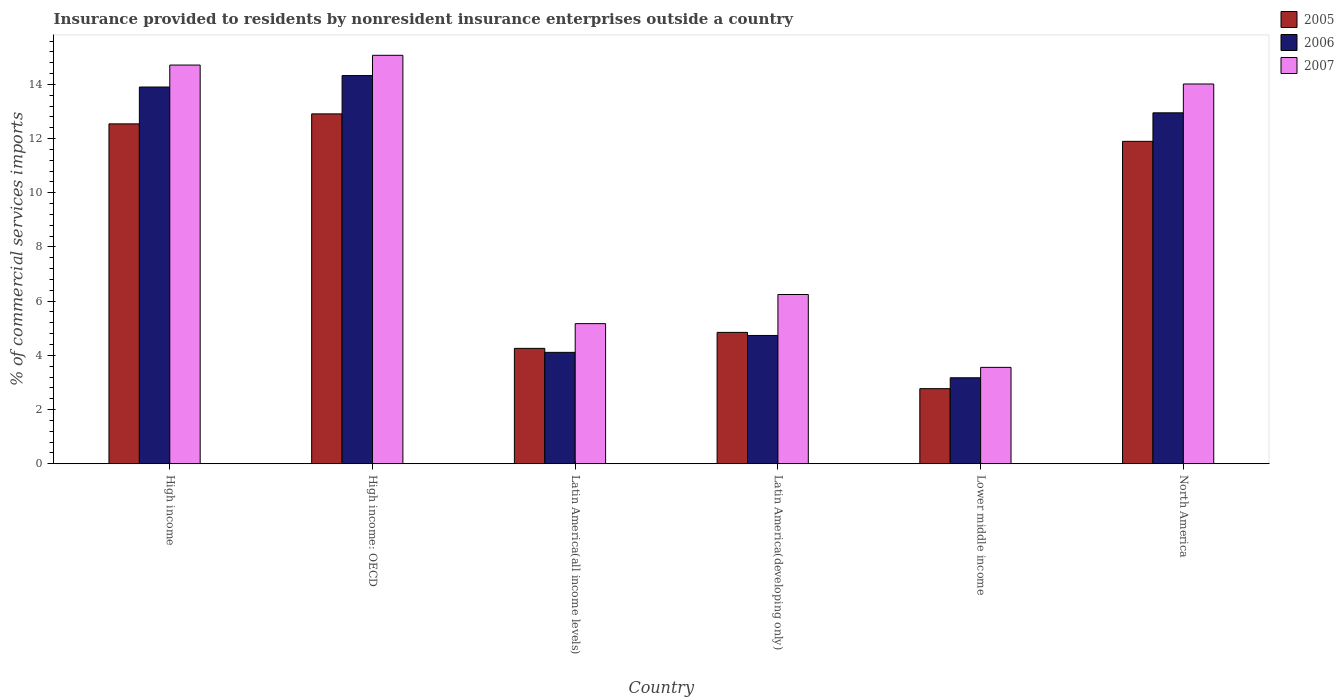Are the number of bars per tick equal to the number of legend labels?
Keep it short and to the point. Yes. How many bars are there on the 1st tick from the right?
Ensure brevity in your answer.  3. What is the label of the 5th group of bars from the left?
Provide a short and direct response. Lower middle income. In how many cases, is the number of bars for a given country not equal to the number of legend labels?
Keep it short and to the point. 0. What is the Insurance provided to residents in 2006 in Lower middle income?
Offer a very short reply. 3.17. Across all countries, what is the maximum Insurance provided to residents in 2006?
Provide a short and direct response. 14.33. Across all countries, what is the minimum Insurance provided to residents in 2007?
Make the answer very short. 3.56. In which country was the Insurance provided to residents in 2005 maximum?
Give a very brief answer. High income: OECD. In which country was the Insurance provided to residents in 2005 minimum?
Offer a very short reply. Lower middle income. What is the total Insurance provided to residents in 2006 in the graph?
Make the answer very short. 53.19. What is the difference between the Insurance provided to residents in 2007 in High income and that in Lower middle income?
Ensure brevity in your answer.  11.16. What is the difference between the Insurance provided to residents in 2007 in High income and the Insurance provided to residents in 2006 in North America?
Provide a succinct answer. 1.76. What is the average Insurance provided to residents in 2005 per country?
Ensure brevity in your answer.  8.2. What is the difference between the Insurance provided to residents of/in 2006 and Insurance provided to residents of/in 2007 in Lower middle income?
Provide a short and direct response. -0.38. In how many countries, is the Insurance provided to residents in 2006 greater than 1.6 %?
Ensure brevity in your answer.  6. What is the ratio of the Insurance provided to residents in 2005 in High income to that in Latin America(all income levels)?
Offer a very short reply. 2.95. What is the difference between the highest and the second highest Insurance provided to residents in 2005?
Give a very brief answer. -1.01. What is the difference between the highest and the lowest Insurance provided to residents in 2007?
Keep it short and to the point. 11.52. What is the difference between two consecutive major ticks on the Y-axis?
Provide a short and direct response. 2. Are the values on the major ticks of Y-axis written in scientific E-notation?
Keep it short and to the point. No. How are the legend labels stacked?
Your answer should be very brief. Vertical. What is the title of the graph?
Offer a terse response. Insurance provided to residents by nonresident insurance enterprises outside a country. Does "1972" appear as one of the legend labels in the graph?
Keep it short and to the point. No. What is the label or title of the X-axis?
Give a very brief answer. Country. What is the label or title of the Y-axis?
Give a very brief answer. % of commercial services imports. What is the % of commercial services imports in 2005 in High income?
Provide a succinct answer. 12.54. What is the % of commercial services imports of 2006 in High income?
Provide a succinct answer. 13.9. What is the % of commercial services imports of 2007 in High income?
Offer a very short reply. 14.71. What is the % of commercial services imports in 2005 in High income: OECD?
Your answer should be compact. 12.91. What is the % of commercial services imports in 2006 in High income: OECD?
Provide a succinct answer. 14.33. What is the % of commercial services imports of 2007 in High income: OECD?
Give a very brief answer. 15.07. What is the % of commercial services imports of 2005 in Latin America(all income levels)?
Offer a terse response. 4.26. What is the % of commercial services imports of 2006 in Latin America(all income levels)?
Offer a terse response. 4.11. What is the % of commercial services imports in 2007 in Latin America(all income levels)?
Provide a succinct answer. 5.17. What is the % of commercial services imports of 2005 in Latin America(developing only)?
Your answer should be compact. 4.85. What is the % of commercial services imports in 2006 in Latin America(developing only)?
Ensure brevity in your answer.  4.73. What is the % of commercial services imports of 2007 in Latin America(developing only)?
Make the answer very short. 6.25. What is the % of commercial services imports of 2005 in Lower middle income?
Provide a short and direct response. 2.77. What is the % of commercial services imports in 2006 in Lower middle income?
Offer a very short reply. 3.17. What is the % of commercial services imports of 2007 in Lower middle income?
Your answer should be compact. 3.56. What is the % of commercial services imports in 2005 in North America?
Offer a very short reply. 11.9. What is the % of commercial services imports of 2006 in North America?
Offer a terse response. 12.95. What is the % of commercial services imports in 2007 in North America?
Make the answer very short. 14.01. Across all countries, what is the maximum % of commercial services imports in 2005?
Provide a succinct answer. 12.91. Across all countries, what is the maximum % of commercial services imports in 2006?
Offer a very short reply. 14.33. Across all countries, what is the maximum % of commercial services imports in 2007?
Offer a very short reply. 15.07. Across all countries, what is the minimum % of commercial services imports of 2005?
Provide a succinct answer. 2.77. Across all countries, what is the minimum % of commercial services imports in 2006?
Your answer should be compact. 3.17. Across all countries, what is the minimum % of commercial services imports of 2007?
Provide a short and direct response. 3.56. What is the total % of commercial services imports in 2005 in the graph?
Your answer should be very brief. 49.23. What is the total % of commercial services imports of 2006 in the graph?
Provide a succinct answer. 53.19. What is the total % of commercial services imports of 2007 in the graph?
Offer a terse response. 58.77. What is the difference between the % of commercial services imports of 2005 in High income and that in High income: OECD?
Your answer should be very brief. -0.37. What is the difference between the % of commercial services imports in 2006 in High income and that in High income: OECD?
Ensure brevity in your answer.  -0.42. What is the difference between the % of commercial services imports of 2007 in High income and that in High income: OECD?
Provide a succinct answer. -0.36. What is the difference between the % of commercial services imports of 2005 in High income and that in Latin America(all income levels)?
Keep it short and to the point. 8.28. What is the difference between the % of commercial services imports in 2006 in High income and that in Latin America(all income levels)?
Your answer should be very brief. 9.79. What is the difference between the % of commercial services imports of 2007 in High income and that in Latin America(all income levels)?
Keep it short and to the point. 9.54. What is the difference between the % of commercial services imports in 2005 in High income and that in Latin America(developing only)?
Give a very brief answer. 7.69. What is the difference between the % of commercial services imports of 2006 in High income and that in Latin America(developing only)?
Keep it short and to the point. 9.17. What is the difference between the % of commercial services imports in 2007 in High income and that in Latin America(developing only)?
Your answer should be compact. 8.47. What is the difference between the % of commercial services imports in 2005 in High income and that in Lower middle income?
Keep it short and to the point. 9.77. What is the difference between the % of commercial services imports of 2006 in High income and that in Lower middle income?
Make the answer very short. 10.73. What is the difference between the % of commercial services imports of 2007 in High income and that in Lower middle income?
Your answer should be compact. 11.16. What is the difference between the % of commercial services imports in 2005 in High income and that in North America?
Your response must be concise. 0.64. What is the difference between the % of commercial services imports of 2006 in High income and that in North America?
Make the answer very short. 0.95. What is the difference between the % of commercial services imports in 2007 in High income and that in North America?
Offer a terse response. 0.7. What is the difference between the % of commercial services imports in 2005 in High income: OECD and that in Latin America(all income levels)?
Keep it short and to the point. 8.65. What is the difference between the % of commercial services imports in 2006 in High income: OECD and that in Latin America(all income levels)?
Provide a short and direct response. 10.21. What is the difference between the % of commercial services imports of 2007 in High income: OECD and that in Latin America(all income levels)?
Your answer should be compact. 9.9. What is the difference between the % of commercial services imports in 2005 in High income: OECD and that in Latin America(developing only)?
Provide a succinct answer. 8.06. What is the difference between the % of commercial services imports in 2006 in High income: OECD and that in Latin America(developing only)?
Offer a very short reply. 9.59. What is the difference between the % of commercial services imports of 2007 in High income: OECD and that in Latin America(developing only)?
Make the answer very short. 8.83. What is the difference between the % of commercial services imports of 2005 in High income: OECD and that in Lower middle income?
Provide a short and direct response. 10.14. What is the difference between the % of commercial services imports in 2006 in High income: OECD and that in Lower middle income?
Keep it short and to the point. 11.15. What is the difference between the % of commercial services imports in 2007 in High income: OECD and that in Lower middle income?
Make the answer very short. 11.52. What is the difference between the % of commercial services imports of 2005 in High income: OECD and that in North America?
Keep it short and to the point. 1.01. What is the difference between the % of commercial services imports in 2006 in High income: OECD and that in North America?
Keep it short and to the point. 1.38. What is the difference between the % of commercial services imports in 2007 in High income: OECD and that in North America?
Your answer should be compact. 1.06. What is the difference between the % of commercial services imports in 2005 in Latin America(all income levels) and that in Latin America(developing only)?
Keep it short and to the point. -0.59. What is the difference between the % of commercial services imports in 2006 in Latin America(all income levels) and that in Latin America(developing only)?
Ensure brevity in your answer.  -0.62. What is the difference between the % of commercial services imports of 2007 in Latin America(all income levels) and that in Latin America(developing only)?
Give a very brief answer. -1.07. What is the difference between the % of commercial services imports of 2005 in Latin America(all income levels) and that in Lower middle income?
Your answer should be compact. 1.49. What is the difference between the % of commercial services imports in 2006 in Latin America(all income levels) and that in Lower middle income?
Give a very brief answer. 0.94. What is the difference between the % of commercial services imports of 2007 in Latin America(all income levels) and that in Lower middle income?
Offer a very short reply. 1.61. What is the difference between the % of commercial services imports in 2005 in Latin America(all income levels) and that in North America?
Keep it short and to the point. -7.64. What is the difference between the % of commercial services imports of 2006 in Latin America(all income levels) and that in North America?
Ensure brevity in your answer.  -8.84. What is the difference between the % of commercial services imports in 2007 in Latin America(all income levels) and that in North America?
Your answer should be very brief. -8.84. What is the difference between the % of commercial services imports in 2005 in Latin America(developing only) and that in Lower middle income?
Ensure brevity in your answer.  2.08. What is the difference between the % of commercial services imports of 2006 in Latin America(developing only) and that in Lower middle income?
Give a very brief answer. 1.56. What is the difference between the % of commercial services imports in 2007 in Latin America(developing only) and that in Lower middle income?
Provide a succinct answer. 2.69. What is the difference between the % of commercial services imports of 2005 in Latin America(developing only) and that in North America?
Make the answer very short. -7.05. What is the difference between the % of commercial services imports of 2006 in Latin America(developing only) and that in North America?
Offer a very short reply. -8.22. What is the difference between the % of commercial services imports in 2007 in Latin America(developing only) and that in North America?
Make the answer very short. -7.77. What is the difference between the % of commercial services imports of 2005 in Lower middle income and that in North America?
Keep it short and to the point. -9.13. What is the difference between the % of commercial services imports of 2006 in Lower middle income and that in North America?
Offer a very short reply. -9.78. What is the difference between the % of commercial services imports of 2007 in Lower middle income and that in North America?
Your answer should be compact. -10.46. What is the difference between the % of commercial services imports of 2005 in High income and the % of commercial services imports of 2006 in High income: OECD?
Offer a terse response. -1.78. What is the difference between the % of commercial services imports in 2005 in High income and the % of commercial services imports in 2007 in High income: OECD?
Your answer should be compact. -2.53. What is the difference between the % of commercial services imports in 2006 in High income and the % of commercial services imports in 2007 in High income: OECD?
Provide a short and direct response. -1.17. What is the difference between the % of commercial services imports of 2005 in High income and the % of commercial services imports of 2006 in Latin America(all income levels)?
Offer a very short reply. 8.43. What is the difference between the % of commercial services imports in 2005 in High income and the % of commercial services imports in 2007 in Latin America(all income levels)?
Ensure brevity in your answer.  7.37. What is the difference between the % of commercial services imports of 2006 in High income and the % of commercial services imports of 2007 in Latin America(all income levels)?
Offer a terse response. 8.73. What is the difference between the % of commercial services imports in 2005 in High income and the % of commercial services imports in 2006 in Latin America(developing only)?
Keep it short and to the point. 7.81. What is the difference between the % of commercial services imports of 2005 in High income and the % of commercial services imports of 2007 in Latin America(developing only)?
Your answer should be very brief. 6.3. What is the difference between the % of commercial services imports in 2006 in High income and the % of commercial services imports in 2007 in Latin America(developing only)?
Your answer should be very brief. 7.66. What is the difference between the % of commercial services imports of 2005 in High income and the % of commercial services imports of 2006 in Lower middle income?
Your response must be concise. 9.37. What is the difference between the % of commercial services imports of 2005 in High income and the % of commercial services imports of 2007 in Lower middle income?
Keep it short and to the point. 8.99. What is the difference between the % of commercial services imports in 2006 in High income and the % of commercial services imports in 2007 in Lower middle income?
Your answer should be very brief. 10.35. What is the difference between the % of commercial services imports of 2005 in High income and the % of commercial services imports of 2006 in North America?
Offer a terse response. -0.41. What is the difference between the % of commercial services imports in 2005 in High income and the % of commercial services imports in 2007 in North America?
Ensure brevity in your answer.  -1.47. What is the difference between the % of commercial services imports in 2006 in High income and the % of commercial services imports in 2007 in North America?
Make the answer very short. -0.11. What is the difference between the % of commercial services imports in 2005 in High income: OECD and the % of commercial services imports in 2006 in Latin America(all income levels)?
Your response must be concise. 8.8. What is the difference between the % of commercial services imports of 2005 in High income: OECD and the % of commercial services imports of 2007 in Latin America(all income levels)?
Your answer should be very brief. 7.74. What is the difference between the % of commercial services imports in 2006 in High income: OECD and the % of commercial services imports in 2007 in Latin America(all income levels)?
Provide a short and direct response. 9.15. What is the difference between the % of commercial services imports in 2005 in High income: OECD and the % of commercial services imports in 2006 in Latin America(developing only)?
Your response must be concise. 8.18. What is the difference between the % of commercial services imports of 2005 in High income: OECD and the % of commercial services imports of 2007 in Latin America(developing only)?
Ensure brevity in your answer.  6.67. What is the difference between the % of commercial services imports of 2006 in High income: OECD and the % of commercial services imports of 2007 in Latin America(developing only)?
Offer a terse response. 8.08. What is the difference between the % of commercial services imports in 2005 in High income: OECD and the % of commercial services imports in 2006 in Lower middle income?
Keep it short and to the point. 9.74. What is the difference between the % of commercial services imports in 2005 in High income: OECD and the % of commercial services imports in 2007 in Lower middle income?
Give a very brief answer. 9.35. What is the difference between the % of commercial services imports in 2006 in High income: OECD and the % of commercial services imports in 2007 in Lower middle income?
Provide a succinct answer. 10.77. What is the difference between the % of commercial services imports of 2005 in High income: OECD and the % of commercial services imports of 2006 in North America?
Offer a terse response. -0.04. What is the difference between the % of commercial services imports in 2005 in High income: OECD and the % of commercial services imports in 2007 in North America?
Your answer should be very brief. -1.1. What is the difference between the % of commercial services imports of 2006 in High income: OECD and the % of commercial services imports of 2007 in North America?
Provide a short and direct response. 0.31. What is the difference between the % of commercial services imports of 2005 in Latin America(all income levels) and the % of commercial services imports of 2006 in Latin America(developing only)?
Make the answer very short. -0.48. What is the difference between the % of commercial services imports in 2005 in Latin America(all income levels) and the % of commercial services imports in 2007 in Latin America(developing only)?
Keep it short and to the point. -1.99. What is the difference between the % of commercial services imports of 2006 in Latin America(all income levels) and the % of commercial services imports of 2007 in Latin America(developing only)?
Your answer should be very brief. -2.13. What is the difference between the % of commercial services imports of 2005 in Latin America(all income levels) and the % of commercial services imports of 2006 in Lower middle income?
Give a very brief answer. 1.08. What is the difference between the % of commercial services imports in 2005 in Latin America(all income levels) and the % of commercial services imports in 2007 in Lower middle income?
Your response must be concise. 0.7. What is the difference between the % of commercial services imports in 2006 in Latin America(all income levels) and the % of commercial services imports in 2007 in Lower middle income?
Offer a very short reply. 0.55. What is the difference between the % of commercial services imports of 2005 in Latin America(all income levels) and the % of commercial services imports of 2006 in North America?
Your response must be concise. -8.69. What is the difference between the % of commercial services imports in 2005 in Latin America(all income levels) and the % of commercial services imports in 2007 in North America?
Give a very brief answer. -9.76. What is the difference between the % of commercial services imports of 2006 in Latin America(all income levels) and the % of commercial services imports of 2007 in North America?
Offer a very short reply. -9.9. What is the difference between the % of commercial services imports of 2005 in Latin America(developing only) and the % of commercial services imports of 2006 in Lower middle income?
Offer a terse response. 1.67. What is the difference between the % of commercial services imports in 2005 in Latin America(developing only) and the % of commercial services imports in 2007 in Lower middle income?
Keep it short and to the point. 1.29. What is the difference between the % of commercial services imports of 2006 in Latin America(developing only) and the % of commercial services imports of 2007 in Lower middle income?
Give a very brief answer. 1.18. What is the difference between the % of commercial services imports of 2005 in Latin America(developing only) and the % of commercial services imports of 2006 in North America?
Keep it short and to the point. -8.1. What is the difference between the % of commercial services imports of 2005 in Latin America(developing only) and the % of commercial services imports of 2007 in North America?
Give a very brief answer. -9.17. What is the difference between the % of commercial services imports in 2006 in Latin America(developing only) and the % of commercial services imports in 2007 in North America?
Offer a terse response. -9.28. What is the difference between the % of commercial services imports of 2005 in Lower middle income and the % of commercial services imports of 2006 in North America?
Keep it short and to the point. -10.18. What is the difference between the % of commercial services imports in 2005 in Lower middle income and the % of commercial services imports in 2007 in North America?
Offer a terse response. -11.24. What is the difference between the % of commercial services imports of 2006 in Lower middle income and the % of commercial services imports of 2007 in North America?
Your answer should be very brief. -10.84. What is the average % of commercial services imports in 2005 per country?
Offer a very short reply. 8.2. What is the average % of commercial services imports in 2006 per country?
Give a very brief answer. 8.87. What is the average % of commercial services imports in 2007 per country?
Your response must be concise. 9.8. What is the difference between the % of commercial services imports of 2005 and % of commercial services imports of 2006 in High income?
Your answer should be compact. -1.36. What is the difference between the % of commercial services imports of 2005 and % of commercial services imports of 2007 in High income?
Your answer should be compact. -2.17. What is the difference between the % of commercial services imports of 2006 and % of commercial services imports of 2007 in High income?
Your answer should be compact. -0.81. What is the difference between the % of commercial services imports in 2005 and % of commercial services imports in 2006 in High income: OECD?
Your answer should be very brief. -1.41. What is the difference between the % of commercial services imports of 2005 and % of commercial services imports of 2007 in High income: OECD?
Make the answer very short. -2.16. What is the difference between the % of commercial services imports of 2006 and % of commercial services imports of 2007 in High income: OECD?
Keep it short and to the point. -0.75. What is the difference between the % of commercial services imports in 2005 and % of commercial services imports in 2006 in Latin America(all income levels)?
Your answer should be compact. 0.15. What is the difference between the % of commercial services imports in 2005 and % of commercial services imports in 2007 in Latin America(all income levels)?
Your response must be concise. -0.91. What is the difference between the % of commercial services imports of 2006 and % of commercial services imports of 2007 in Latin America(all income levels)?
Provide a succinct answer. -1.06. What is the difference between the % of commercial services imports of 2005 and % of commercial services imports of 2006 in Latin America(developing only)?
Ensure brevity in your answer.  0.11. What is the difference between the % of commercial services imports of 2005 and % of commercial services imports of 2007 in Latin America(developing only)?
Keep it short and to the point. -1.4. What is the difference between the % of commercial services imports of 2006 and % of commercial services imports of 2007 in Latin America(developing only)?
Give a very brief answer. -1.51. What is the difference between the % of commercial services imports of 2005 and % of commercial services imports of 2006 in Lower middle income?
Offer a terse response. -0.4. What is the difference between the % of commercial services imports of 2005 and % of commercial services imports of 2007 in Lower middle income?
Offer a very short reply. -0.79. What is the difference between the % of commercial services imports in 2006 and % of commercial services imports in 2007 in Lower middle income?
Give a very brief answer. -0.38. What is the difference between the % of commercial services imports of 2005 and % of commercial services imports of 2006 in North America?
Provide a short and direct response. -1.05. What is the difference between the % of commercial services imports of 2005 and % of commercial services imports of 2007 in North America?
Ensure brevity in your answer.  -2.12. What is the difference between the % of commercial services imports of 2006 and % of commercial services imports of 2007 in North America?
Provide a short and direct response. -1.06. What is the ratio of the % of commercial services imports in 2005 in High income to that in High income: OECD?
Give a very brief answer. 0.97. What is the ratio of the % of commercial services imports of 2006 in High income to that in High income: OECD?
Ensure brevity in your answer.  0.97. What is the ratio of the % of commercial services imports in 2007 in High income to that in High income: OECD?
Give a very brief answer. 0.98. What is the ratio of the % of commercial services imports in 2005 in High income to that in Latin America(all income levels)?
Ensure brevity in your answer.  2.95. What is the ratio of the % of commercial services imports in 2006 in High income to that in Latin America(all income levels)?
Give a very brief answer. 3.38. What is the ratio of the % of commercial services imports in 2007 in High income to that in Latin America(all income levels)?
Your response must be concise. 2.85. What is the ratio of the % of commercial services imports of 2005 in High income to that in Latin America(developing only)?
Give a very brief answer. 2.59. What is the ratio of the % of commercial services imports in 2006 in High income to that in Latin America(developing only)?
Your answer should be very brief. 2.94. What is the ratio of the % of commercial services imports of 2007 in High income to that in Latin America(developing only)?
Keep it short and to the point. 2.36. What is the ratio of the % of commercial services imports in 2005 in High income to that in Lower middle income?
Offer a terse response. 4.53. What is the ratio of the % of commercial services imports of 2006 in High income to that in Lower middle income?
Your response must be concise. 4.38. What is the ratio of the % of commercial services imports in 2007 in High income to that in Lower middle income?
Your response must be concise. 4.14. What is the ratio of the % of commercial services imports in 2005 in High income to that in North America?
Give a very brief answer. 1.05. What is the ratio of the % of commercial services imports in 2006 in High income to that in North America?
Ensure brevity in your answer.  1.07. What is the ratio of the % of commercial services imports in 2007 in High income to that in North America?
Keep it short and to the point. 1.05. What is the ratio of the % of commercial services imports of 2005 in High income: OECD to that in Latin America(all income levels)?
Provide a short and direct response. 3.03. What is the ratio of the % of commercial services imports in 2006 in High income: OECD to that in Latin America(all income levels)?
Ensure brevity in your answer.  3.48. What is the ratio of the % of commercial services imports in 2007 in High income: OECD to that in Latin America(all income levels)?
Your answer should be very brief. 2.92. What is the ratio of the % of commercial services imports in 2005 in High income: OECD to that in Latin America(developing only)?
Provide a short and direct response. 2.66. What is the ratio of the % of commercial services imports in 2006 in High income: OECD to that in Latin America(developing only)?
Provide a short and direct response. 3.03. What is the ratio of the % of commercial services imports of 2007 in High income: OECD to that in Latin America(developing only)?
Your response must be concise. 2.41. What is the ratio of the % of commercial services imports of 2005 in High income: OECD to that in Lower middle income?
Provide a short and direct response. 4.66. What is the ratio of the % of commercial services imports in 2006 in High income: OECD to that in Lower middle income?
Provide a succinct answer. 4.52. What is the ratio of the % of commercial services imports of 2007 in High income: OECD to that in Lower middle income?
Make the answer very short. 4.24. What is the ratio of the % of commercial services imports in 2005 in High income: OECD to that in North America?
Make the answer very short. 1.09. What is the ratio of the % of commercial services imports of 2006 in High income: OECD to that in North America?
Your answer should be very brief. 1.11. What is the ratio of the % of commercial services imports in 2007 in High income: OECD to that in North America?
Your response must be concise. 1.08. What is the ratio of the % of commercial services imports in 2005 in Latin America(all income levels) to that in Latin America(developing only)?
Keep it short and to the point. 0.88. What is the ratio of the % of commercial services imports of 2006 in Latin America(all income levels) to that in Latin America(developing only)?
Your response must be concise. 0.87. What is the ratio of the % of commercial services imports in 2007 in Latin America(all income levels) to that in Latin America(developing only)?
Your answer should be very brief. 0.83. What is the ratio of the % of commercial services imports of 2005 in Latin America(all income levels) to that in Lower middle income?
Ensure brevity in your answer.  1.54. What is the ratio of the % of commercial services imports in 2006 in Latin America(all income levels) to that in Lower middle income?
Provide a succinct answer. 1.3. What is the ratio of the % of commercial services imports in 2007 in Latin America(all income levels) to that in Lower middle income?
Offer a terse response. 1.45. What is the ratio of the % of commercial services imports in 2005 in Latin America(all income levels) to that in North America?
Ensure brevity in your answer.  0.36. What is the ratio of the % of commercial services imports of 2006 in Latin America(all income levels) to that in North America?
Offer a terse response. 0.32. What is the ratio of the % of commercial services imports of 2007 in Latin America(all income levels) to that in North America?
Your response must be concise. 0.37. What is the ratio of the % of commercial services imports of 2005 in Latin America(developing only) to that in Lower middle income?
Give a very brief answer. 1.75. What is the ratio of the % of commercial services imports in 2006 in Latin America(developing only) to that in Lower middle income?
Keep it short and to the point. 1.49. What is the ratio of the % of commercial services imports of 2007 in Latin America(developing only) to that in Lower middle income?
Your answer should be compact. 1.76. What is the ratio of the % of commercial services imports of 2005 in Latin America(developing only) to that in North America?
Provide a succinct answer. 0.41. What is the ratio of the % of commercial services imports in 2006 in Latin America(developing only) to that in North America?
Offer a terse response. 0.37. What is the ratio of the % of commercial services imports in 2007 in Latin America(developing only) to that in North America?
Offer a very short reply. 0.45. What is the ratio of the % of commercial services imports of 2005 in Lower middle income to that in North America?
Keep it short and to the point. 0.23. What is the ratio of the % of commercial services imports in 2006 in Lower middle income to that in North America?
Offer a terse response. 0.24. What is the ratio of the % of commercial services imports of 2007 in Lower middle income to that in North America?
Provide a short and direct response. 0.25. What is the difference between the highest and the second highest % of commercial services imports of 2005?
Your response must be concise. 0.37. What is the difference between the highest and the second highest % of commercial services imports of 2006?
Your answer should be very brief. 0.42. What is the difference between the highest and the second highest % of commercial services imports in 2007?
Make the answer very short. 0.36. What is the difference between the highest and the lowest % of commercial services imports in 2005?
Keep it short and to the point. 10.14. What is the difference between the highest and the lowest % of commercial services imports of 2006?
Make the answer very short. 11.15. What is the difference between the highest and the lowest % of commercial services imports in 2007?
Provide a succinct answer. 11.52. 